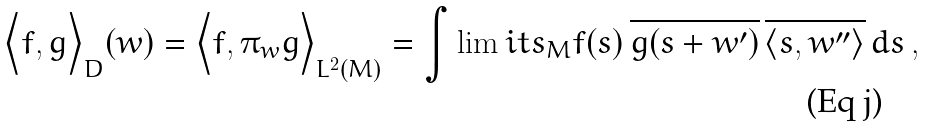<formula> <loc_0><loc_0><loc_500><loc_500>\Big < f , g \Big > _ { D } ( w ) = \Big < f , \pi _ { w } g \Big > _ { L ^ { 2 } ( M ) } = \int \lim i t s _ { M } f ( s ) \, \overline { g ( s + w ^ { \prime } ) } \, \overline { \langle s , w ^ { \prime \prime } \rangle } \, d s \, ,</formula> 